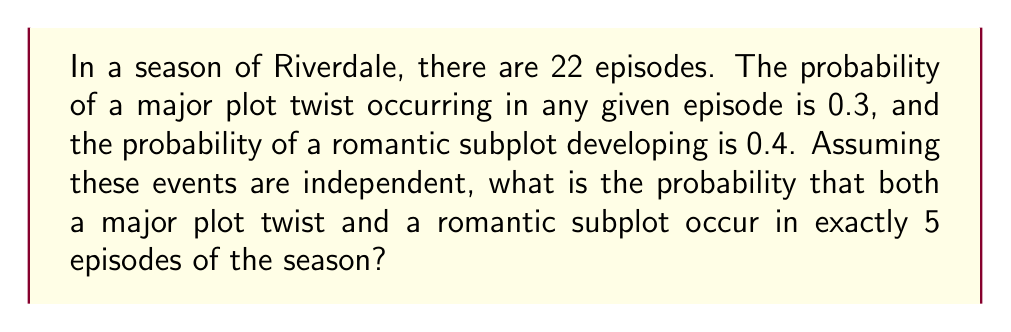Give your solution to this math problem. Let's approach this step-by-step:

1) This is a binomial probability problem where we're looking for the probability of exactly 5 successes in 22 trials.

2) Let's define success as an episode having both a major plot twist and a romantic subplot.

3) The probability of both events occurring in a single episode is:
   $P(\text{both}) = P(\text{plot twist}) \times P(\text{romantic subplot}) = 0.3 \times 0.4 = 0.12$

4) Now we can use the binomial probability formula:

   $$P(X = k) = \binom{n}{k} p^k (1-p)^{n-k}$$

   Where:
   $n = 22$ (total number of episodes)
   $k = 5$ (number of episodes we want both events to occur)
   $p = 0.12$ (probability of both events occurring in a single episode)

5) Plugging in the values:

   $$P(X = 5) = \binom{22}{5} (0.12)^5 (1-0.12)^{22-5}$$

6) Simplify:
   $$P(X = 5) = 26334 \times (0.12)^5 \times (0.88)^{17}$$

7) Calculate:
   $$P(X = 5) \approx 0.1401$$
Answer: $0.1401$ or $14.01\%$ 